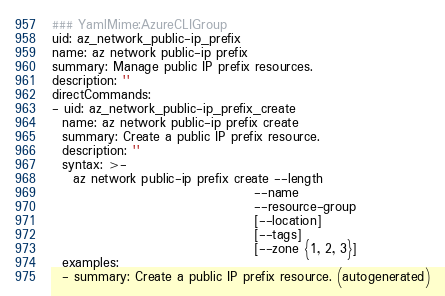Convert code to text. <code><loc_0><loc_0><loc_500><loc_500><_YAML_>### YamlMime:AzureCLIGroup
uid: az_network_public-ip_prefix
name: az network public-ip prefix
summary: Manage public IP prefix resources.
description: ''
directCommands:
- uid: az_network_public-ip_prefix_create
  name: az network public-ip prefix create
  summary: Create a public IP prefix resource.
  description: ''
  syntax: >-
    az network public-ip prefix create --length
                                       --name
                                       --resource-group
                                       [--location]
                                       [--tags]
                                       [--zone {1, 2, 3}]
  examples:
  - summary: Create a public IP prefix resource. (autogenerated)</code> 